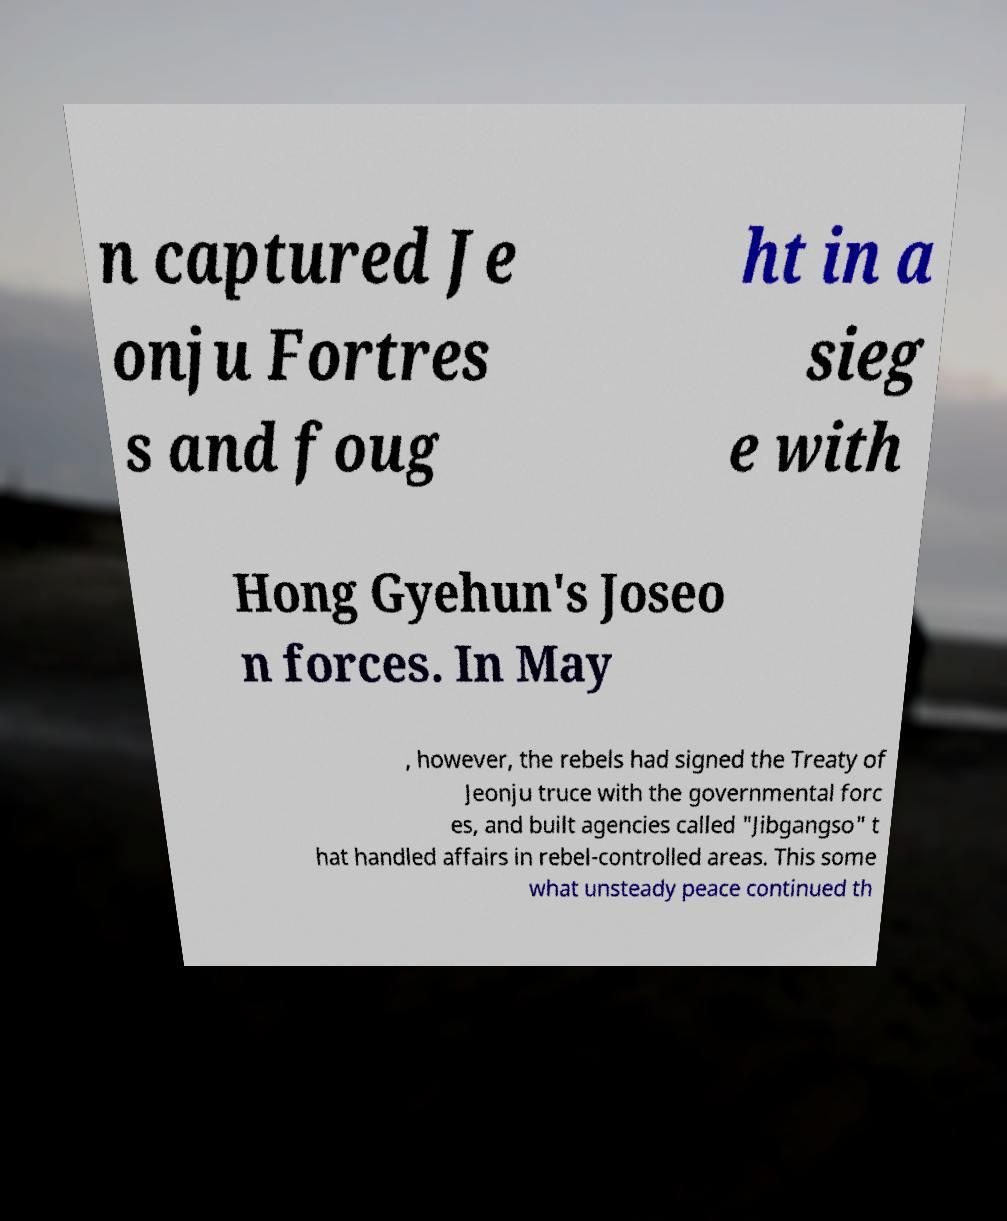There's text embedded in this image that I need extracted. Can you transcribe it verbatim? n captured Je onju Fortres s and foug ht in a sieg e with Hong Gyehun's Joseo n forces. In May , however, the rebels had signed the Treaty of Jeonju truce with the governmental forc es, and built agencies called "Jibgangso" t hat handled affairs in rebel-controlled areas. This some what unsteady peace continued th 